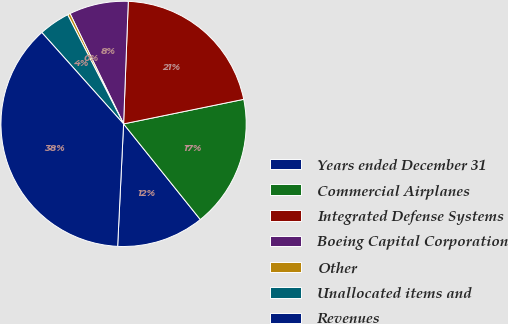Convert chart to OTSL. <chart><loc_0><loc_0><loc_500><loc_500><pie_chart><fcel>Years ended December 31<fcel>Commercial Airplanes<fcel>Integrated Defense Systems<fcel>Boeing Capital Corporation<fcel>Other<fcel>Unallocated items and<fcel>Revenues<nl><fcel>11.53%<fcel>17.45%<fcel>21.18%<fcel>7.8%<fcel>0.35%<fcel>4.08%<fcel>37.61%<nl></chart> 